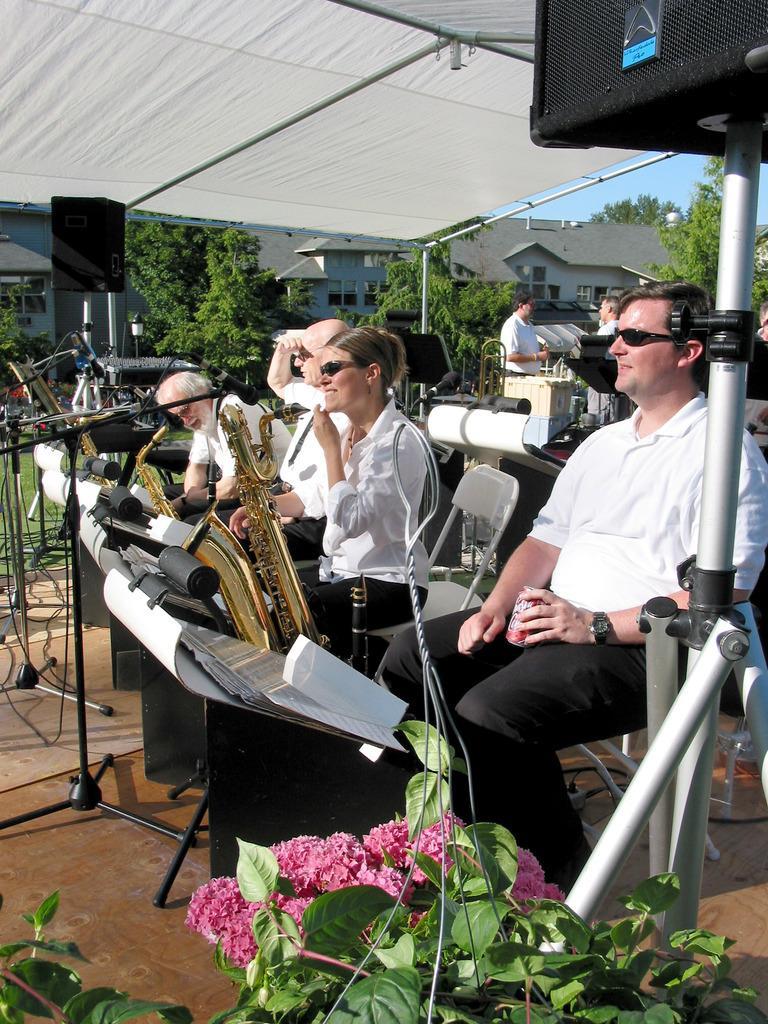Please provide a concise description of this image. In this image few people are sitting on the chair. Before them there are few strands having papers. There are few musical instruments. People are under the tent. Bottom of the image there are few plants having flowers. Background there are few trees and buildings. Right side few people are standing. 